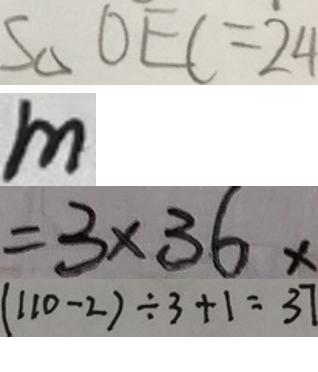Convert formula to latex. <formula><loc_0><loc_0><loc_500><loc_500>S \Delta O E C = 2 4 
 m 
 = 3 \times 3 6 x 
 ( 1 1 0 - 2 ) \div 3 + 1 = 3 7</formula> 